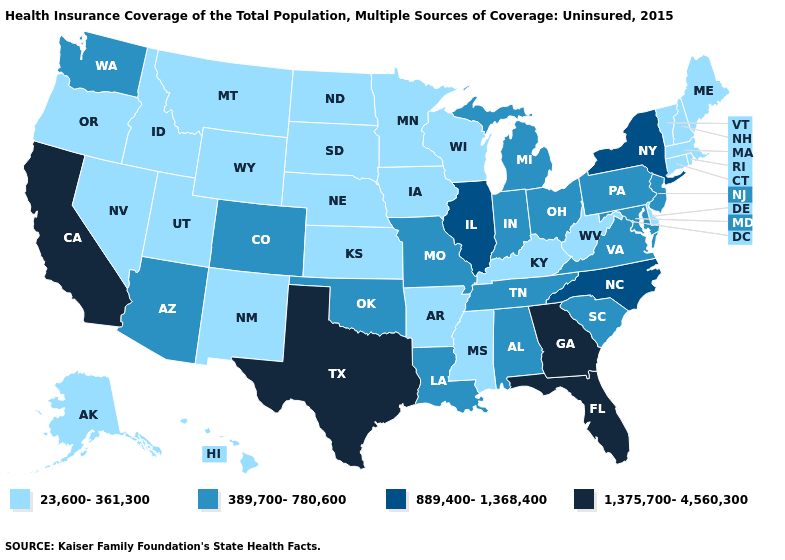Does Connecticut have the lowest value in the USA?
Concise answer only. Yes. Does Vermont have a lower value than Ohio?
Concise answer only. Yes. Name the states that have a value in the range 389,700-780,600?
Short answer required. Alabama, Arizona, Colorado, Indiana, Louisiana, Maryland, Michigan, Missouri, New Jersey, Ohio, Oklahoma, Pennsylvania, South Carolina, Tennessee, Virginia, Washington. Name the states that have a value in the range 389,700-780,600?
Be succinct. Alabama, Arizona, Colorado, Indiana, Louisiana, Maryland, Michigan, Missouri, New Jersey, Ohio, Oklahoma, Pennsylvania, South Carolina, Tennessee, Virginia, Washington. Among the states that border Nevada , which have the lowest value?
Answer briefly. Idaho, Oregon, Utah. Is the legend a continuous bar?
Be succinct. No. What is the highest value in the USA?
Concise answer only. 1,375,700-4,560,300. Name the states that have a value in the range 889,400-1,368,400?
Short answer required. Illinois, New York, North Carolina. Which states have the lowest value in the USA?
Keep it brief. Alaska, Arkansas, Connecticut, Delaware, Hawaii, Idaho, Iowa, Kansas, Kentucky, Maine, Massachusetts, Minnesota, Mississippi, Montana, Nebraska, Nevada, New Hampshire, New Mexico, North Dakota, Oregon, Rhode Island, South Dakota, Utah, Vermont, West Virginia, Wisconsin, Wyoming. What is the value of New York?
Be succinct. 889,400-1,368,400. Name the states that have a value in the range 389,700-780,600?
Be succinct. Alabama, Arizona, Colorado, Indiana, Louisiana, Maryland, Michigan, Missouri, New Jersey, Ohio, Oklahoma, Pennsylvania, South Carolina, Tennessee, Virginia, Washington. Among the states that border South Carolina , does North Carolina have the lowest value?
Be succinct. Yes. Which states have the lowest value in the South?
Answer briefly. Arkansas, Delaware, Kentucky, Mississippi, West Virginia. Name the states that have a value in the range 23,600-361,300?
Concise answer only. Alaska, Arkansas, Connecticut, Delaware, Hawaii, Idaho, Iowa, Kansas, Kentucky, Maine, Massachusetts, Minnesota, Mississippi, Montana, Nebraska, Nevada, New Hampshire, New Mexico, North Dakota, Oregon, Rhode Island, South Dakota, Utah, Vermont, West Virginia, Wisconsin, Wyoming. What is the value of New Jersey?
Concise answer only. 389,700-780,600. 